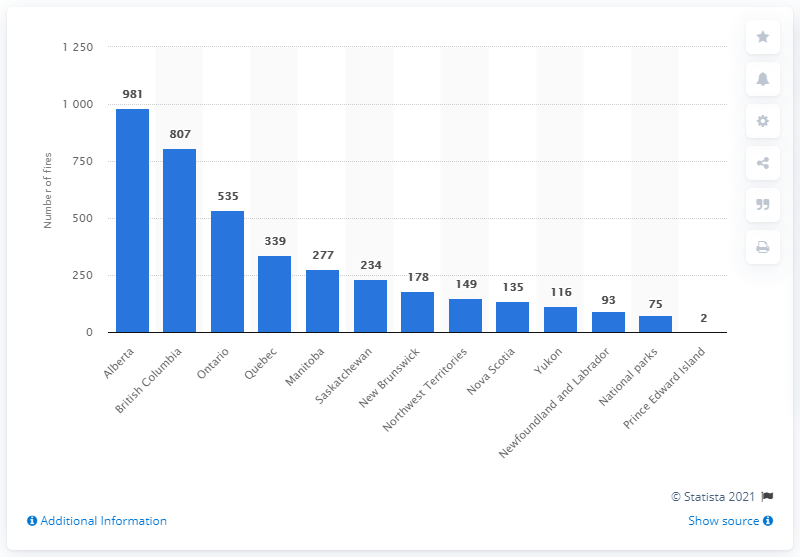Outline some significant characteristics in this image. In 2019, there were 981 forest fires in the province of Alberta. 